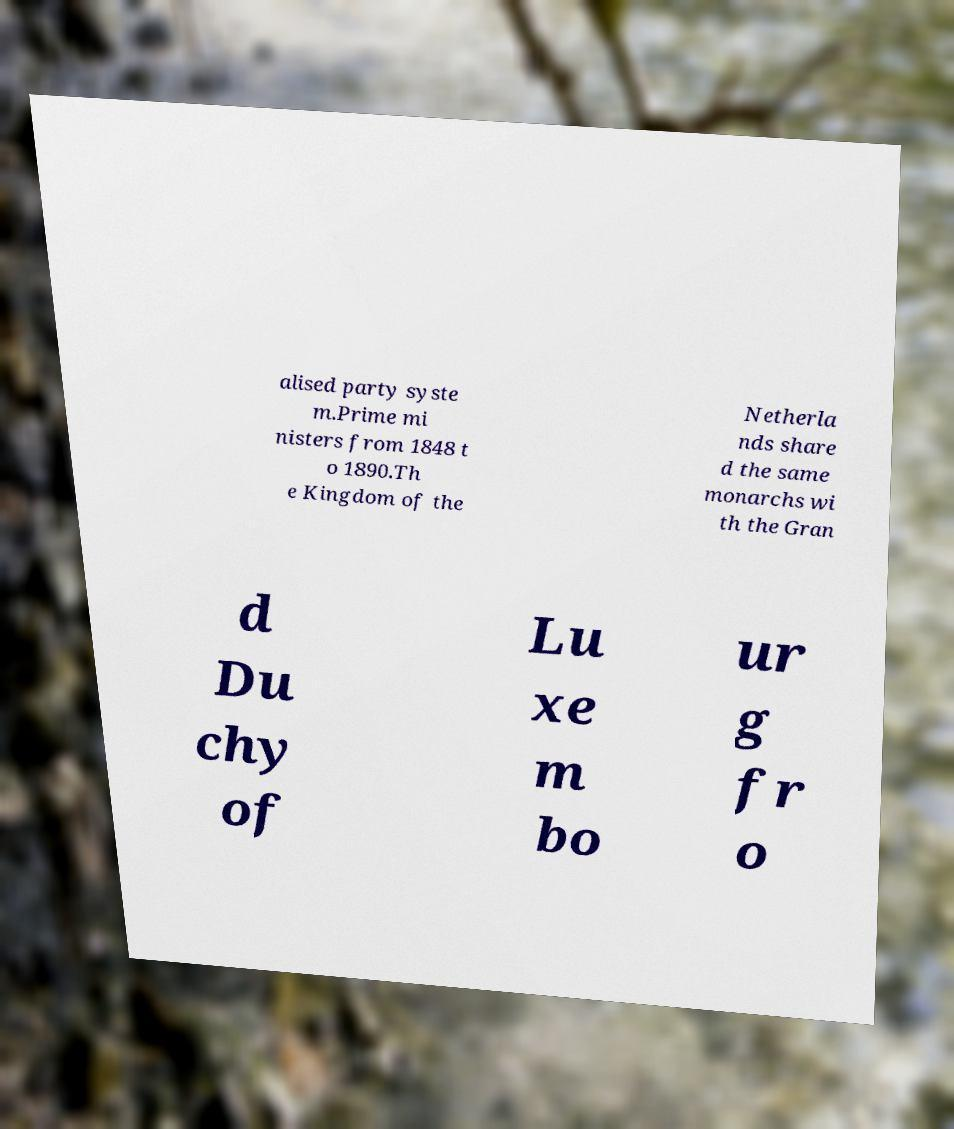I need the written content from this picture converted into text. Can you do that? alised party syste m.Prime mi nisters from 1848 t o 1890.Th e Kingdom of the Netherla nds share d the same monarchs wi th the Gran d Du chy of Lu xe m bo ur g fr o 